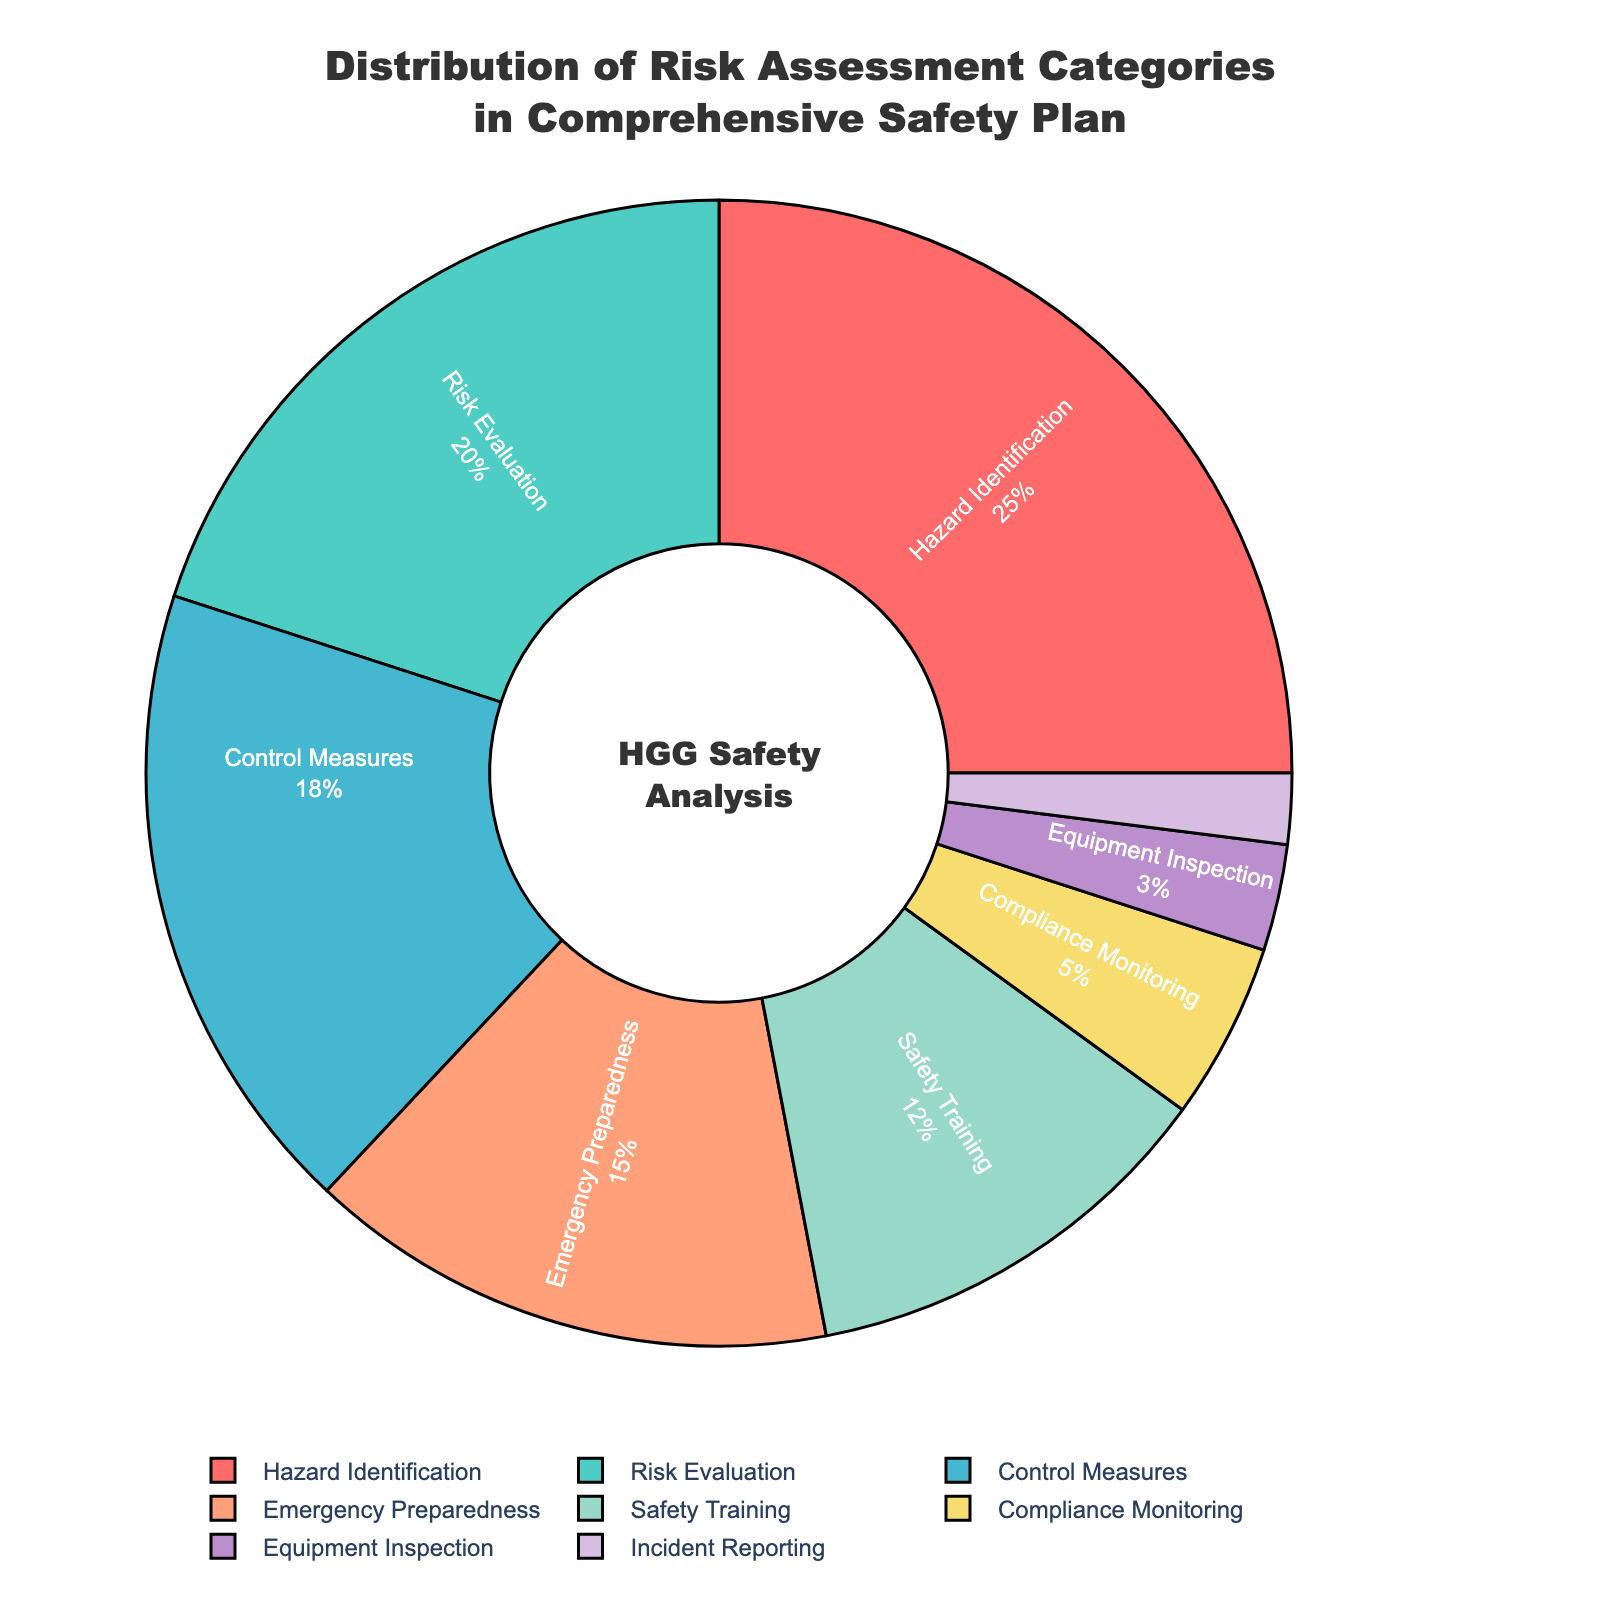Which category has the highest percentage in the pie chart? The category with the highest percentage is identified by looking at the largest segment in the pie chart. Here, "Hazard Identification" has the largest segment.
Answer: Hazard Identification Which two categories combined make up almost half of the total percentage? To find this, look for two categories whose combined percentages are closest to 50%. "Hazard Identification" is 25% and "Risk Evaluation" is 20%, together they make 45%.
Answer: Hazard Identification and Risk Evaluation What percentage is represented by categories related to training and emergency procedures combined? Add the percentages of "Emergency Preparedness" (15%) and "Safety Training" (12%). 15% + 12% = 27%.
Answer: 27% Which category contributes the least to the comprehensive safety plan? The smallest segment in the pie chart represents the category that contributes the least. "Incident Reporting" has the smallest segment with 2%.
Answer: Incident Reporting How much larger is the segment for "Control Measures" compared to "Equipment Inspection"? Subtract the percentage of "Equipment Inspection" (3%) from "Control Measures" (18%). 18% - 3% = 15%.
Answer: 15% By how much does the "Hazard Identification" category exceed the "Compliance Monitoring" category? Subtract the percentage of "Compliance Monitoring" (5%) from "Hazard Identification" (25%). 25% - 5% = 20%.
Answer: 20% Which two categories combined represent less than a quarter of the safety plan? Look for two categories whose percentages total less than 25%. "Equipment Inspection" (3%) and "Incident Reporting" (2%) combined give 5%, which is less than 25%.
Answer: Equipment Inspection and Incident Reporting What is the percentage difference between "Risk Evaluation" and "Safety Training"? Subtract the percentage of "Safety Training" (12%) from "Risk Evaluation" (20%). 20% - 12% = 8%.
Answer: 8% Which category has a similar contribution to that of "Emergency Preparedness"? Compare percentages visually to find a segment similar in size to "Emergency Preparedness" (15%). "Safety Training" (12%) is the closest.
Answer: Safety Training How many categories contribute more than 10% to the safety plan? Count the number of categories with percentages greater than 10%. These are "Hazard Identification" (25%), "Risk Evaluation" (20%), "Control Measures" (18%), "Emergency Preparedness" (15%), and "Safety Training" (12%). There are 5 such categories.
Answer: 5 